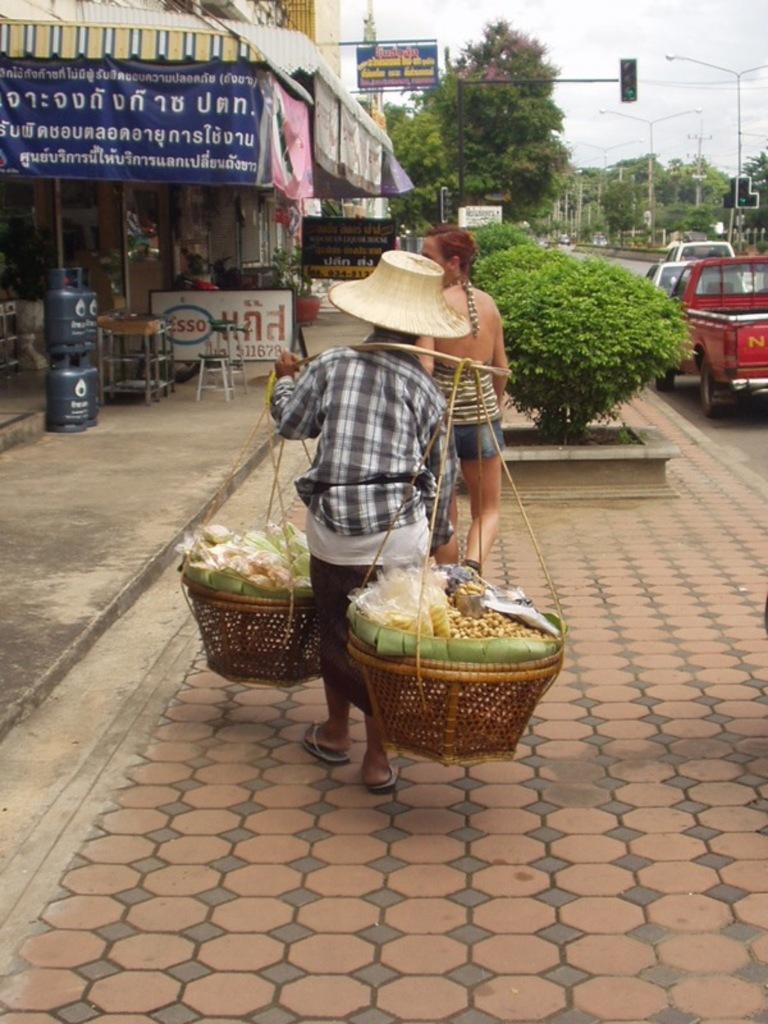In one or two sentences, can you explain what this image depicts? In this image we can see two persons, among them, one person is holding a balance carrier, there are some buildings, trees, chairs, plants, cylinders, poles, lights and boards with some text on it, also we can see the sky. 